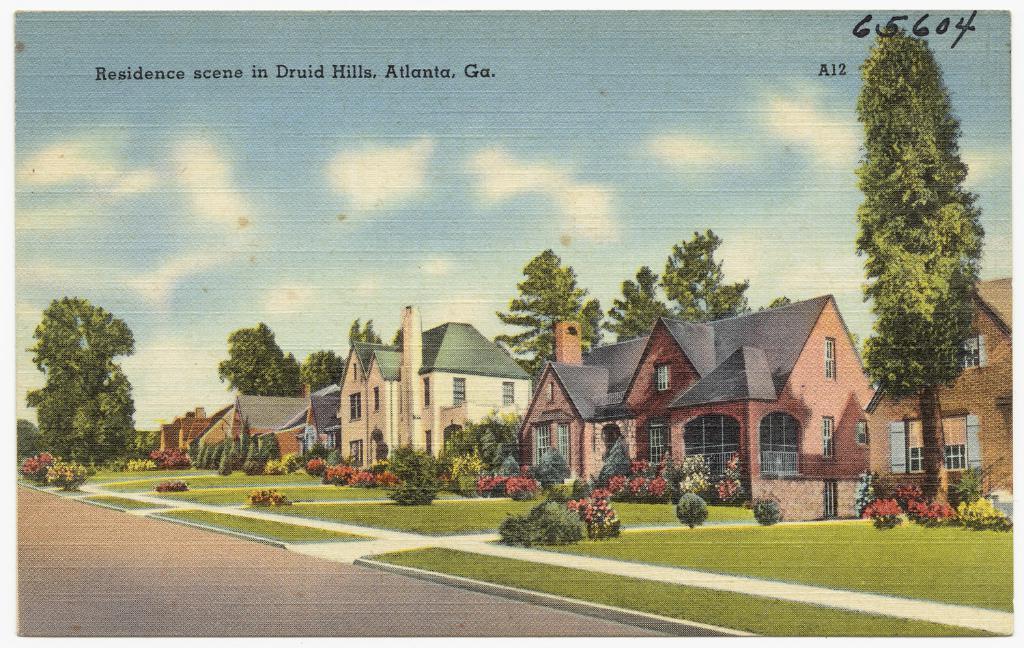In one or two sentences, can you explain what this image depicts? In this image there is a painting of houses, trees and grass on the ground, there is some text written on the image and the sky is cloudy. 